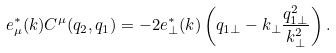Convert formula to latex. <formula><loc_0><loc_0><loc_500><loc_500>e _ { \mu } ^ { * } ( k ) C ^ { \mu } ( q _ { 2 } , q _ { 1 } ) = - 2 e _ { \perp } ^ { * } ( k ) \left ( q _ { 1 \perp } - k _ { \perp } \frac { q _ { 1 \perp } ^ { 2 } } { k _ { \perp } ^ { 2 } } \right ) .</formula> 